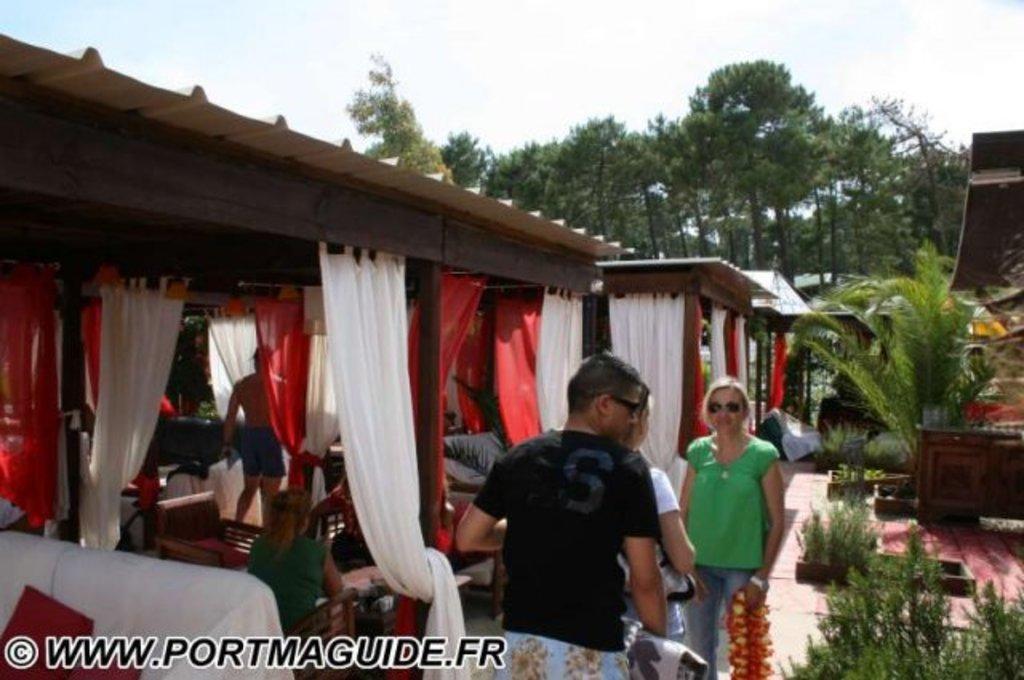How would you summarize this image in a sentence or two? In this picture I can see few people, where one woman is sitting and rest of them are standing. I can also see number of white and red color curtains and I can see the furniture. On the right side of this picture I can see the plants. In the background I can see the sky and the trees. 